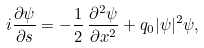Convert formula to latex. <formula><loc_0><loc_0><loc_500><loc_500>i \frac { \partial \psi } { \partial s } = - \frac { 1 } { 2 } \, \frac { \partial ^ { 2 } \psi } { \partial x ^ { 2 } } + q _ { 0 } | \psi | ^ { 2 } \psi ,</formula> 